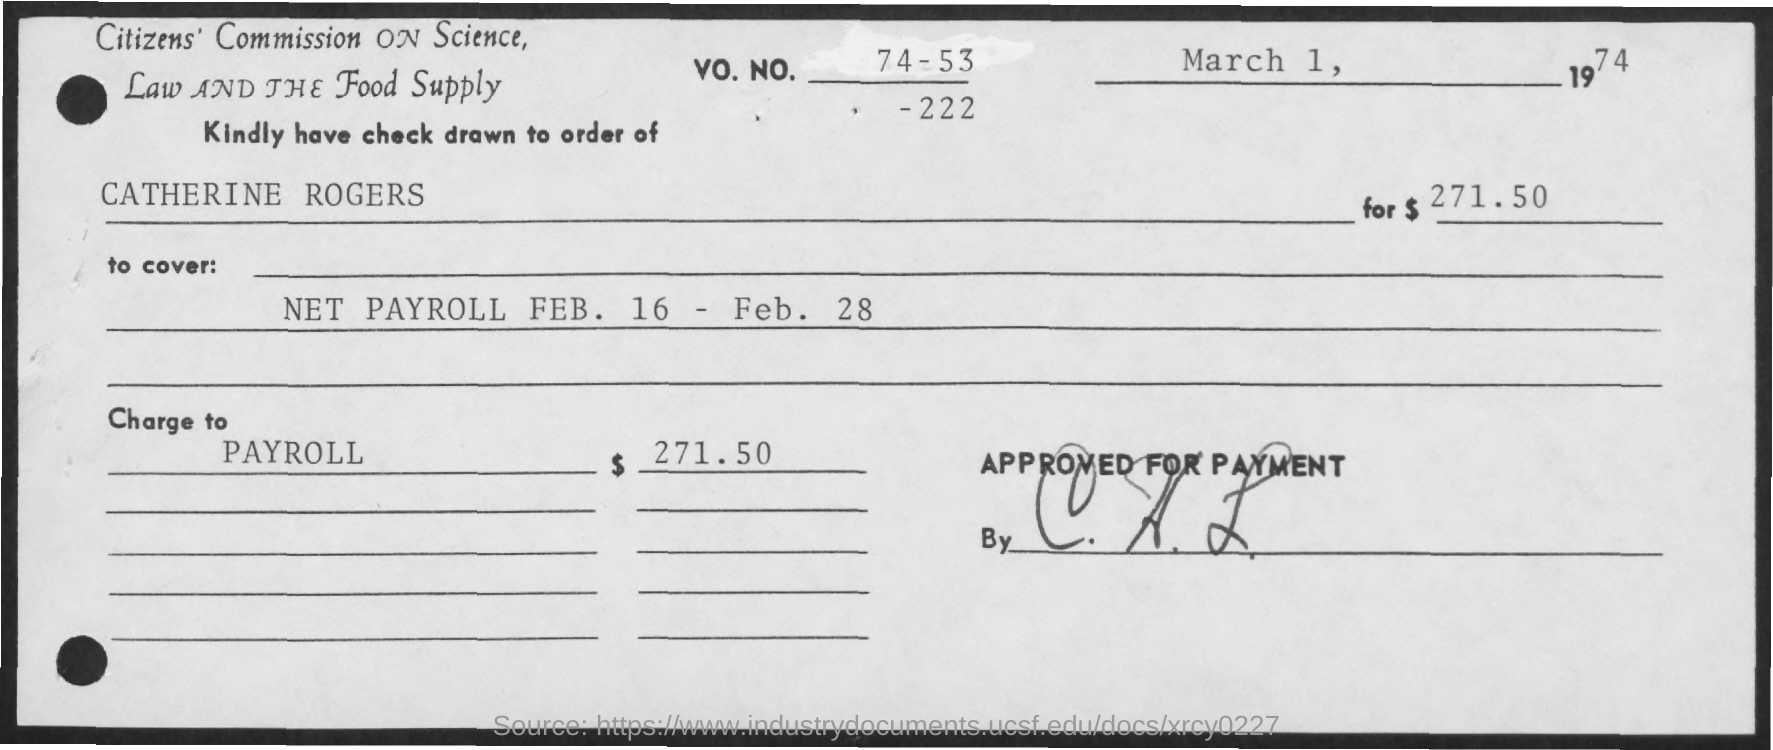Draw attention to some important aspects in this diagram. The date mentioned at the top-right is March 1, 1974. It is necessary to draw this check in the order of Catherine Rogers. The amount mentioned is $271.50. This check is being charged to PAYROLL. 